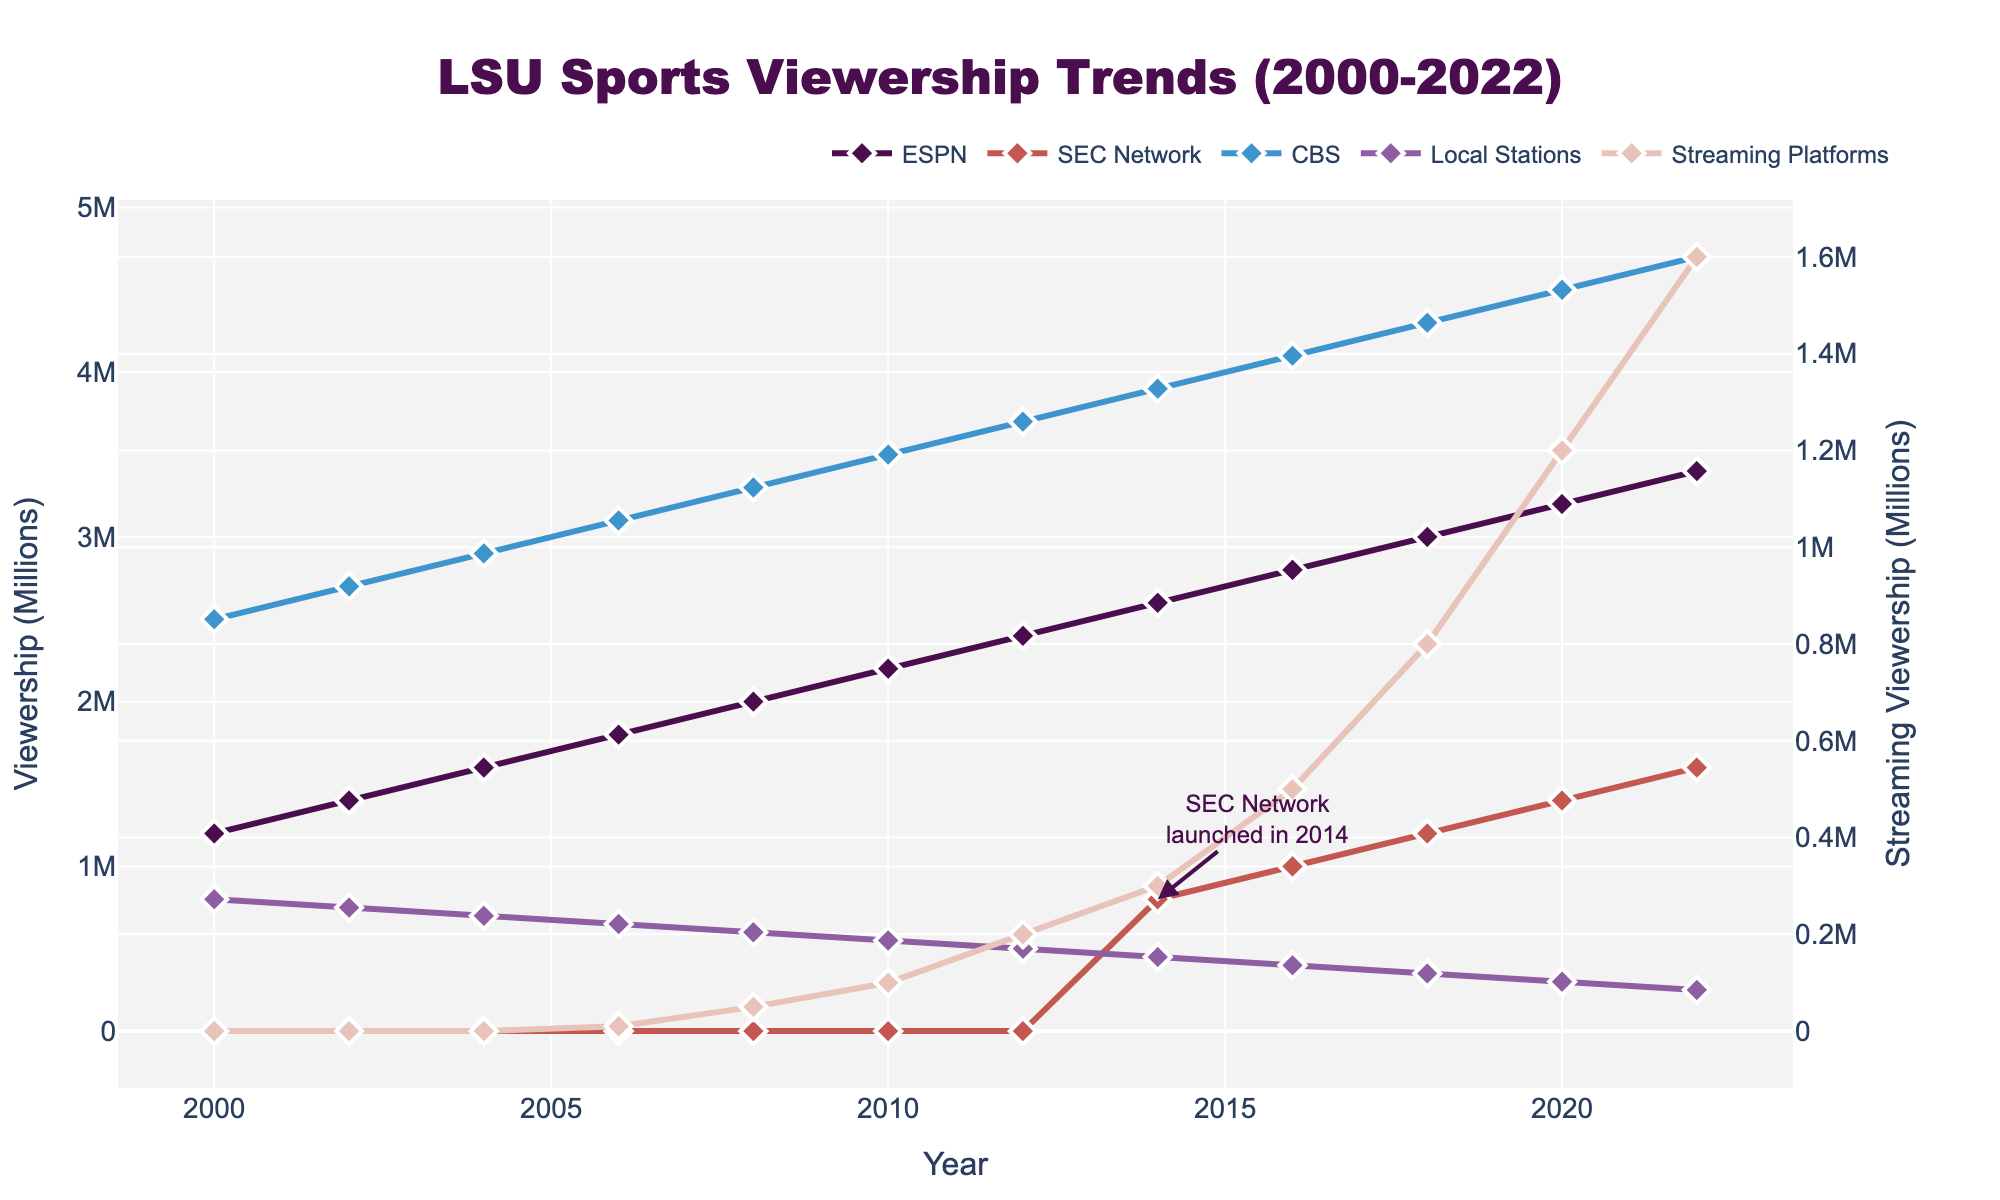Which platform had the highest viewership in 2022? By looking at the highest point on the graph for the year 2022, we see that CBS had the highest viewership.
Answer: CBS How has viewership on ESPN changed from 2000 to 2022? In 2000, ESPN had 1,200,000 viewers. By 2022, this number grew to 3,400,000. This indicates a steady increase over the years.
Answer: Increased Which channel saw a significant increase in viewership starting in 2014? Noticing the annotated text and the sharp increase in viewership at 2014, the SEC Network had a significant increase starting that year.
Answer: SEC Network What is the combined viewership for all channels and platforms in 2012? Summing the viewership numbers for all channels in 2012: ESPN (2,400,000) + CBS (3,700,000) + Local Stations (500,000) + Streaming Platforms (200,000) results in a total of 6,800,000.
Answer: 6,800,000 How much did the viewership on streaming platforms increase between 2016 and 2022? Subtracting the viewership of streaming platforms in 2016 (500,000) from the viewership in 2022 (1,600,000) gives an increase of 1,100,000.
Answer: 1,100,000 Which color represents the viewership trend on CBS? By observing the colored lines and their matching names, CBS is represented by the third color in the legend, which is light blue.
Answer: Light blue In what year did local station viewership drop below 500,000? By checking the Local Stations line, viewership dropped below 500,000 in 2014.
Answer: 2014 What is the difference in viewership between ESPN and SEC Network in 2018? In 2018, ESPN had 3,000,000 viewers, and SEC Network had 1,200,000. Subtracting these numbers gives a difference of 1,800,000.
Answer: 1,800,000 How many total viewership channels or platforms were tracked in the year 2000? In the year 2000, viewership was only tracked for three channels or platforms: ESPN, CBS, and Local Stations.
Answer: 3 What visual mark identifies data points on the lines for each platform or channel? Each line on the plot is marked with diamonds at the data points.
Answer: Diamonds 